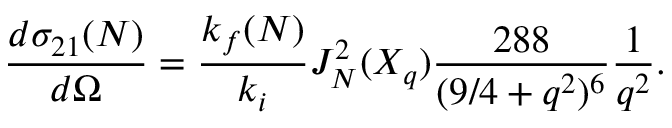Convert formula to latex. <formula><loc_0><loc_0><loc_500><loc_500>\frac { d { \sigma } _ { 2 1 } ( N ) } { d \Omega } = \frac { k _ { f } ( N ) } { k _ { i } } J _ { N } ^ { 2 } ( X _ { q } ) \frac { 2 8 8 } { ( 9 / 4 + q ^ { 2 } ) ^ { 6 } } \frac { 1 } { q ^ { 2 } } .</formula> 